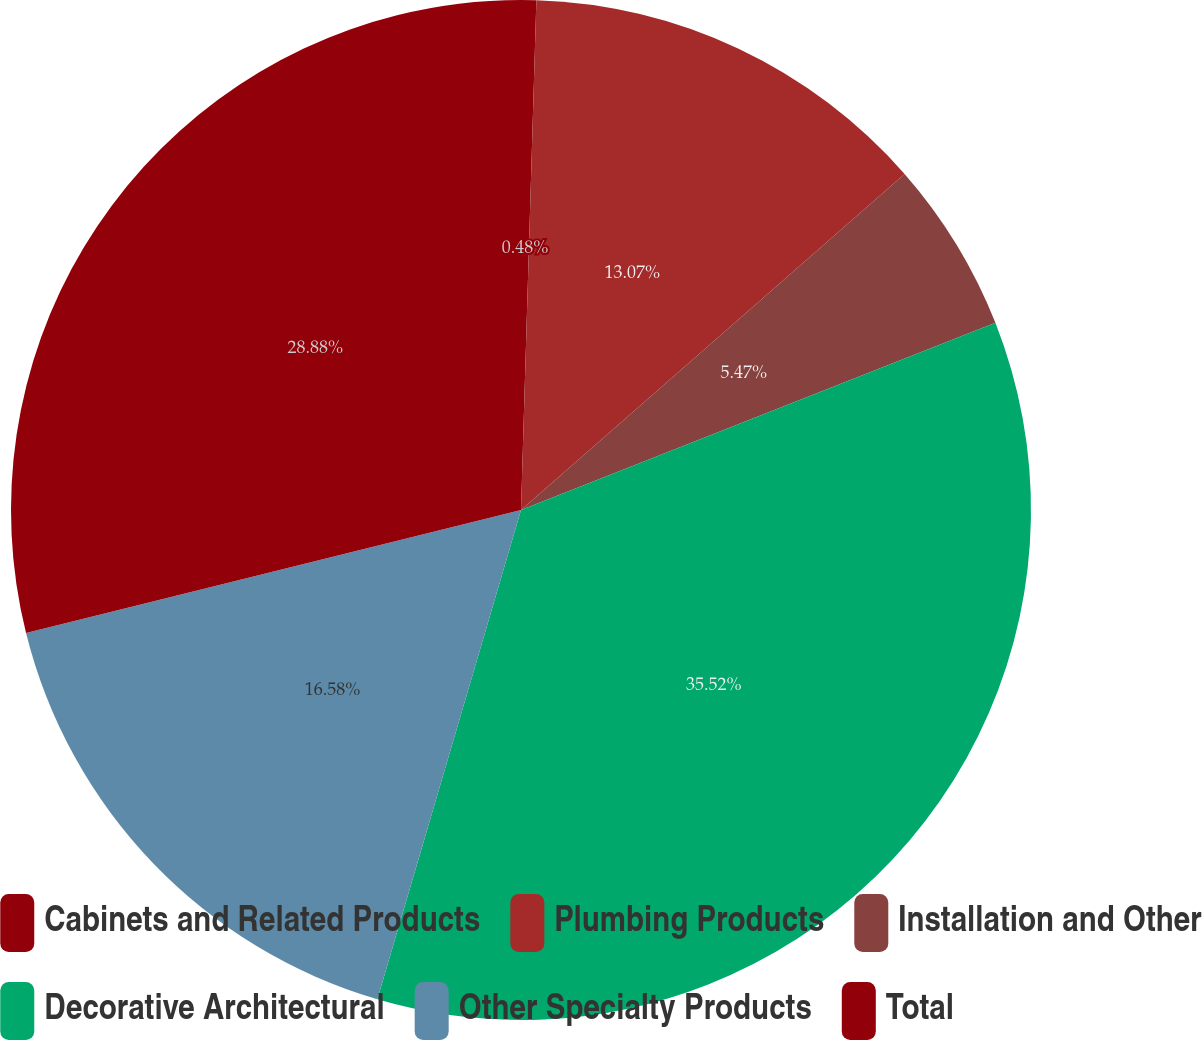Convert chart. <chart><loc_0><loc_0><loc_500><loc_500><pie_chart><fcel>Cabinets and Related Products<fcel>Plumbing Products<fcel>Installation and Other<fcel>Decorative Architectural<fcel>Other Specialty Products<fcel>Total<nl><fcel>0.48%<fcel>13.07%<fcel>5.47%<fcel>35.53%<fcel>16.58%<fcel>28.88%<nl></chart> 